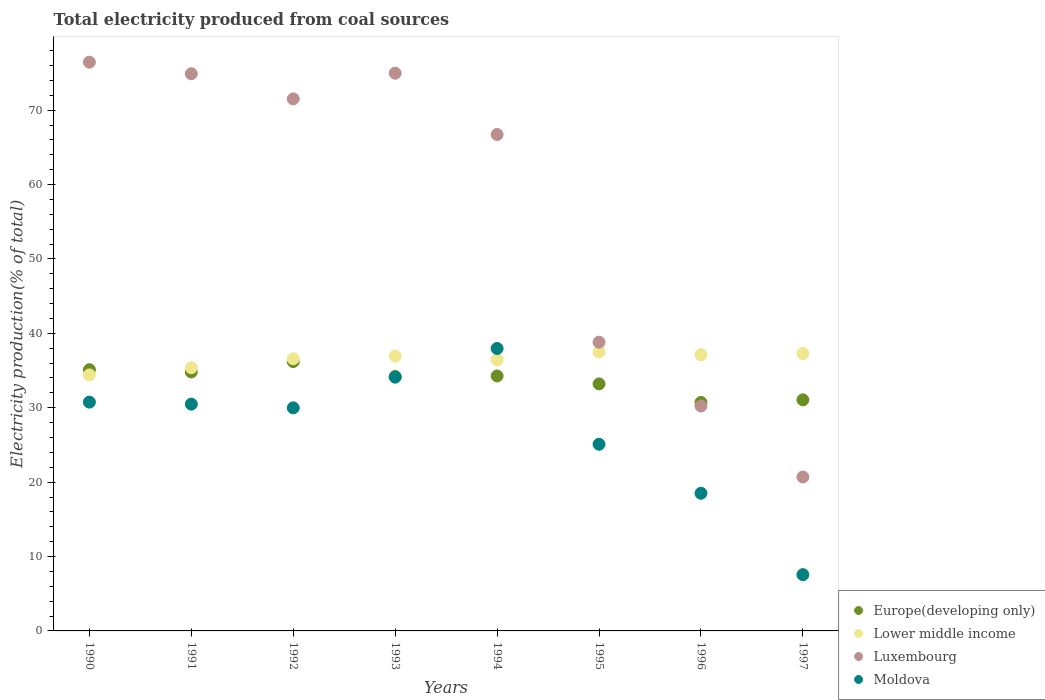Is the number of dotlines equal to the number of legend labels?
Offer a very short reply. Yes. What is the total electricity produced in Moldova in 1995?
Offer a terse response. 25.09. Across all years, what is the maximum total electricity produced in Moldova?
Your response must be concise. 37.96. Across all years, what is the minimum total electricity produced in Europe(developing only)?
Offer a very short reply. 30.71. In which year was the total electricity produced in Moldova maximum?
Keep it short and to the point. 1994. What is the total total electricity produced in Lower middle income in the graph?
Your response must be concise. 291.69. What is the difference between the total electricity produced in Luxembourg in 1993 and that in 1997?
Provide a short and direct response. 54.27. What is the difference between the total electricity produced in Moldova in 1994 and the total electricity produced in Lower middle income in 1996?
Provide a short and direct response. 0.83. What is the average total electricity produced in Luxembourg per year?
Make the answer very short. 56.78. In the year 1994, what is the difference between the total electricity produced in Europe(developing only) and total electricity produced in Lower middle income?
Provide a short and direct response. -2.18. In how many years, is the total electricity produced in Luxembourg greater than 52 %?
Make the answer very short. 5. What is the ratio of the total electricity produced in Europe(developing only) in 1990 to that in 1991?
Provide a succinct answer. 1.01. What is the difference between the highest and the second highest total electricity produced in Moldova?
Provide a succinct answer. 3.85. What is the difference between the highest and the lowest total electricity produced in Luxembourg?
Give a very brief answer. 55.75. In how many years, is the total electricity produced in Moldova greater than the average total electricity produced in Moldova taken over all years?
Offer a terse response. 5. Is the sum of the total electricity produced in Moldova in 1990 and 1994 greater than the maximum total electricity produced in Luxembourg across all years?
Give a very brief answer. No. Does the total electricity produced in Lower middle income monotonically increase over the years?
Provide a succinct answer. No. Is the total electricity produced in Luxembourg strictly greater than the total electricity produced in Europe(developing only) over the years?
Ensure brevity in your answer.  No. Is the total electricity produced in Lower middle income strictly less than the total electricity produced in Luxembourg over the years?
Your answer should be compact. No. How many years are there in the graph?
Your response must be concise. 8. Does the graph contain any zero values?
Provide a short and direct response. No. Does the graph contain grids?
Offer a very short reply. No. Where does the legend appear in the graph?
Offer a very short reply. Bottom right. How are the legend labels stacked?
Give a very brief answer. Vertical. What is the title of the graph?
Your response must be concise. Total electricity produced from coal sources. What is the Electricity production(% of total) of Europe(developing only) in 1990?
Ensure brevity in your answer.  35.11. What is the Electricity production(% of total) of Lower middle income in 1990?
Ensure brevity in your answer.  34.41. What is the Electricity production(% of total) of Luxembourg in 1990?
Offer a very short reply. 76.44. What is the Electricity production(% of total) of Moldova in 1990?
Ensure brevity in your answer.  30.75. What is the Electricity production(% of total) of Europe(developing only) in 1991?
Offer a terse response. 34.81. What is the Electricity production(% of total) in Lower middle income in 1991?
Provide a short and direct response. 35.38. What is the Electricity production(% of total) in Luxembourg in 1991?
Your answer should be compact. 74.89. What is the Electricity production(% of total) of Moldova in 1991?
Provide a short and direct response. 30.48. What is the Electricity production(% of total) in Europe(developing only) in 1992?
Make the answer very short. 36.2. What is the Electricity production(% of total) in Lower middle income in 1992?
Offer a terse response. 36.58. What is the Electricity production(% of total) in Luxembourg in 1992?
Offer a very short reply. 71.52. What is the Electricity production(% of total) in Moldova in 1992?
Offer a terse response. 29.99. What is the Electricity production(% of total) of Europe(developing only) in 1993?
Offer a very short reply. 34.2. What is the Electricity production(% of total) in Lower middle income in 1993?
Offer a terse response. 36.94. What is the Electricity production(% of total) in Luxembourg in 1993?
Provide a short and direct response. 74.96. What is the Electricity production(% of total) in Moldova in 1993?
Provide a short and direct response. 34.11. What is the Electricity production(% of total) in Europe(developing only) in 1994?
Ensure brevity in your answer.  34.27. What is the Electricity production(% of total) in Lower middle income in 1994?
Give a very brief answer. 36.46. What is the Electricity production(% of total) in Luxembourg in 1994?
Ensure brevity in your answer.  66.72. What is the Electricity production(% of total) of Moldova in 1994?
Ensure brevity in your answer.  37.96. What is the Electricity production(% of total) in Europe(developing only) in 1995?
Offer a terse response. 33.2. What is the Electricity production(% of total) of Lower middle income in 1995?
Offer a terse response. 37.52. What is the Electricity production(% of total) of Luxembourg in 1995?
Provide a short and direct response. 38.81. What is the Electricity production(% of total) of Moldova in 1995?
Offer a very short reply. 25.09. What is the Electricity production(% of total) of Europe(developing only) in 1996?
Keep it short and to the point. 30.71. What is the Electricity production(% of total) in Lower middle income in 1996?
Ensure brevity in your answer.  37.13. What is the Electricity production(% of total) of Luxembourg in 1996?
Provide a short and direct response. 30.23. What is the Electricity production(% of total) of Moldova in 1996?
Ensure brevity in your answer.  18.5. What is the Electricity production(% of total) in Europe(developing only) in 1997?
Offer a very short reply. 31.06. What is the Electricity production(% of total) in Lower middle income in 1997?
Offer a terse response. 37.27. What is the Electricity production(% of total) of Luxembourg in 1997?
Provide a succinct answer. 20.69. What is the Electricity production(% of total) of Moldova in 1997?
Provide a succinct answer. 7.56. Across all years, what is the maximum Electricity production(% of total) in Europe(developing only)?
Your answer should be very brief. 36.2. Across all years, what is the maximum Electricity production(% of total) of Lower middle income?
Give a very brief answer. 37.52. Across all years, what is the maximum Electricity production(% of total) of Luxembourg?
Give a very brief answer. 76.44. Across all years, what is the maximum Electricity production(% of total) in Moldova?
Provide a succinct answer. 37.96. Across all years, what is the minimum Electricity production(% of total) of Europe(developing only)?
Provide a short and direct response. 30.71. Across all years, what is the minimum Electricity production(% of total) of Lower middle income?
Your answer should be very brief. 34.41. Across all years, what is the minimum Electricity production(% of total) of Luxembourg?
Ensure brevity in your answer.  20.69. Across all years, what is the minimum Electricity production(% of total) of Moldova?
Give a very brief answer. 7.56. What is the total Electricity production(% of total) of Europe(developing only) in the graph?
Your answer should be very brief. 269.57. What is the total Electricity production(% of total) in Lower middle income in the graph?
Keep it short and to the point. 291.69. What is the total Electricity production(% of total) of Luxembourg in the graph?
Offer a very short reply. 454.26. What is the total Electricity production(% of total) in Moldova in the graph?
Ensure brevity in your answer.  214.45. What is the difference between the Electricity production(% of total) in Europe(developing only) in 1990 and that in 1991?
Keep it short and to the point. 0.31. What is the difference between the Electricity production(% of total) in Lower middle income in 1990 and that in 1991?
Your response must be concise. -0.97. What is the difference between the Electricity production(% of total) in Luxembourg in 1990 and that in 1991?
Offer a very short reply. 1.55. What is the difference between the Electricity production(% of total) of Moldova in 1990 and that in 1991?
Keep it short and to the point. 0.27. What is the difference between the Electricity production(% of total) in Europe(developing only) in 1990 and that in 1992?
Provide a succinct answer. -1.09. What is the difference between the Electricity production(% of total) of Lower middle income in 1990 and that in 1992?
Give a very brief answer. -2.18. What is the difference between the Electricity production(% of total) in Luxembourg in 1990 and that in 1992?
Ensure brevity in your answer.  4.93. What is the difference between the Electricity production(% of total) of Moldova in 1990 and that in 1992?
Your response must be concise. 0.76. What is the difference between the Electricity production(% of total) in Europe(developing only) in 1990 and that in 1993?
Provide a succinct answer. 0.91. What is the difference between the Electricity production(% of total) of Lower middle income in 1990 and that in 1993?
Keep it short and to the point. -2.53. What is the difference between the Electricity production(% of total) in Luxembourg in 1990 and that in 1993?
Make the answer very short. 1.48. What is the difference between the Electricity production(% of total) in Moldova in 1990 and that in 1993?
Provide a short and direct response. -3.36. What is the difference between the Electricity production(% of total) of Europe(developing only) in 1990 and that in 1994?
Your answer should be compact. 0.84. What is the difference between the Electricity production(% of total) of Lower middle income in 1990 and that in 1994?
Your answer should be compact. -2.05. What is the difference between the Electricity production(% of total) of Luxembourg in 1990 and that in 1994?
Offer a very short reply. 9.72. What is the difference between the Electricity production(% of total) in Moldova in 1990 and that in 1994?
Your response must be concise. -7.21. What is the difference between the Electricity production(% of total) in Europe(developing only) in 1990 and that in 1995?
Keep it short and to the point. 1.91. What is the difference between the Electricity production(% of total) in Lower middle income in 1990 and that in 1995?
Make the answer very short. -3.11. What is the difference between the Electricity production(% of total) in Luxembourg in 1990 and that in 1995?
Your answer should be very brief. 37.63. What is the difference between the Electricity production(% of total) of Moldova in 1990 and that in 1995?
Offer a terse response. 5.66. What is the difference between the Electricity production(% of total) of Europe(developing only) in 1990 and that in 1996?
Provide a succinct answer. 4.4. What is the difference between the Electricity production(% of total) in Lower middle income in 1990 and that in 1996?
Offer a terse response. -2.72. What is the difference between the Electricity production(% of total) of Luxembourg in 1990 and that in 1996?
Keep it short and to the point. 46.22. What is the difference between the Electricity production(% of total) in Moldova in 1990 and that in 1996?
Your answer should be very brief. 12.25. What is the difference between the Electricity production(% of total) of Europe(developing only) in 1990 and that in 1997?
Make the answer very short. 4.06. What is the difference between the Electricity production(% of total) of Lower middle income in 1990 and that in 1997?
Your answer should be very brief. -2.87. What is the difference between the Electricity production(% of total) of Luxembourg in 1990 and that in 1997?
Offer a very short reply. 55.75. What is the difference between the Electricity production(% of total) of Moldova in 1990 and that in 1997?
Provide a succinct answer. 23.19. What is the difference between the Electricity production(% of total) in Europe(developing only) in 1991 and that in 1992?
Your response must be concise. -1.39. What is the difference between the Electricity production(% of total) of Lower middle income in 1991 and that in 1992?
Make the answer very short. -1.21. What is the difference between the Electricity production(% of total) in Luxembourg in 1991 and that in 1992?
Offer a very short reply. 3.38. What is the difference between the Electricity production(% of total) in Moldova in 1991 and that in 1992?
Make the answer very short. 0.5. What is the difference between the Electricity production(% of total) of Europe(developing only) in 1991 and that in 1993?
Give a very brief answer. 0.61. What is the difference between the Electricity production(% of total) in Lower middle income in 1991 and that in 1993?
Provide a succinct answer. -1.56. What is the difference between the Electricity production(% of total) in Luxembourg in 1991 and that in 1993?
Ensure brevity in your answer.  -0.07. What is the difference between the Electricity production(% of total) in Moldova in 1991 and that in 1993?
Your response must be concise. -3.63. What is the difference between the Electricity production(% of total) of Europe(developing only) in 1991 and that in 1994?
Make the answer very short. 0.54. What is the difference between the Electricity production(% of total) of Lower middle income in 1991 and that in 1994?
Ensure brevity in your answer.  -1.08. What is the difference between the Electricity production(% of total) of Luxembourg in 1991 and that in 1994?
Offer a very short reply. 8.17. What is the difference between the Electricity production(% of total) in Moldova in 1991 and that in 1994?
Give a very brief answer. -7.48. What is the difference between the Electricity production(% of total) of Europe(developing only) in 1991 and that in 1995?
Ensure brevity in your answer.  1.61. What is the difference between the Electricity production(% of total) of Lower middle income in 1991 and that in 1995?
Your response must be concise. -2.14. What is the difference between the Electricity production(% of total) in Luxembourg in 1991 and that in 1995?
Keep it short and to the point. 36.08. What is the difference between the Electricity production(% of total) in Moldova in 1991 and that in 1995?
Keep it short and to the point. 5.39. What is the difference between the Electricity production(% of total) in Europe(developing only) in 1991 and that in 1996?
Provide a succinct answer. 4.1. What is the difference between the Electricity production(% of total) of Lower middle income in 1991 and that in 1996?
Give a very brief answer. -1.75. What is the difference between the Electricity production(% of total) of Luxembourg in 1991 and that in 1996?
Your answer should be compact. 44.67. What is the difference between the Electricity production(% of total) of Moldova in 1991 and that in 1996?
Provide a short and direct response. 11.98. What is the difference between the Electricity production(% of total) of Europe(developing only) in 1991 and that in 1997?
Your answer should be very brief. 3.75. What is the difference between the Electricity production(% of total) of Lower middle income in 1991 and that in 1997?
Your answer should be very brief. -1.9. What is the difference between the Electricity production(% of total) in Luxembourg in 1991 and that in 1997?
Make the answer very short. 54.2. What is the difference between the Electricity production(% of total) in Moldova in 1991 and that in 1997?
Give a very brief answer. 22.92. What is the difference between the Electricity production(% of total) in Europe(developing only) in 1992 and that in 1993?
Provide a succinct answer. 2. What is the difference between the Electricity production(% of total) of Lower middle income in 1992 and that in 1993?
Your answer should be compact. -0.35. What is the difference between the Electricity production(% of total) of Luxembourg in 1992 and that in 1993?
Your answer should be compact. -3.45. What is the difference between the Electricity production(% of total) of Moldova in 1992 and that in 1993?
Ensure brevity in your answer.  -4.12. What is the difference between the Electricity production(% of total) of Europe(developing only) in 1992 and that in 1994?
Give a very brief answer. 1.93. What is the difference between the Electricity production(% of total) in Lower middle income in 1992 and that in 1994?
Ensure brevity in your answer.  0.13. What is the difference between the Electricity production(% of total) of Luxembourg in 1992 and that in 1994?
Your answer should be compact. 4.79. What is the difference between the Electricity production(% of total) of Moldova in 1992 and that in 1994?
Offer a very short reply. -7.98. What is the difference between the Electricity production(% of total) in Europe(developing only) in 1992 and that in 1995?
Your response must be concise. 3. What is the difference between the Electricity production(% of total) of Lower middle income in 1992 and that in 1995?
Your answer should be compact. -0.94. What is the difference between the Electricity production(% of total) in Luxembourg in 1992 and that in 1995?
Your answer should be very brief. 32.71. What is the difference between the Electricity production(% of total) in Moldova in 1992 and that in 1995?
Your response must be concise. 4.9. What is the difference between the Electricity production(% of total) of Europe(developing only) in 1992 and that in 1996?
Ensure brevity in your answer.  5.49. What is the difference between the Electricity production(% of total) in Lower middle income in 1992 and that in 1996?
Provide a short and direct response. -0.55. What is the difference between the Electricity production(% of total) of Luxembourg in 1992 and that in 1996?
Provide a short and direct response. 41.29. What is the difference between the Electricity production(% of total) in Moldova in 1992 and that in 1996?
Give a very brief answer. 11.48. What is the difference between the Electricity production(% of total) in Europe(developing only) in 1992 and that in 1997?
Keep it short and to the point. 5.14. What is the difference between the Electricity production(% of total) in Lower middle income in 1992 and that in 1997?
Your answer should be compact. -0.69. What is the difference between the Electricity production(% of total) of Luxembourg in 1992 and that in 1997?
Offer a terse response. 50.83. What is the difference between the Electricity production(% of total) of Moldova in 1992 and that in 1997?
Keep it short and to the point. 22.42. What is the difference between the Electricity production(% of total) in Europe(developing only) in 1993 and that in 1994?
Provide a succinct answer. -0.07. What is the difference between the Electricity production(% of total) in Lower middle income in 1993 and that in 1994?
Make the answer very short. 0.48. What is the difference between the Electricity production(% of total) of Luxembourg in 1993 and that in 1994?
Keep it short and to the point. 8.24. What is the difference between the Electricity production(% of total) in Moldova in 1993 and that in 1994?
Provide a short and direct response. -3.85. What is the difference between the Electricity production(% of total) of Europe(developing only) in 1993 and that in 1995?
Provide a short and direct response. 1. What is the difference between the Electricity production(% of total) in Lower middle income in 1993 and that in 1995?
Offer a very short reply. -0.58. What is the difference between the Electricity production(% of total) of Luxembourg in 1993 and that in 1995?
Offer a very short reply. 36.15. What is the difference between the Electricity production(% of total) in Moldova in 1993 and that in 1995?
Give a very brief answer. 9.02. What is the difference between the Electricity production(% of total) in Europe(developing only) in 1993 and that in 1996?
Your response must be concise. 3.49. What is the difference between the Electricity production(% of total) in Lower middle income in 1993 and that in 1996?
Provide a succinct answer. -0.19. What is the difference between the Electricity production(% of total) in Luxembourg in 1993 and that in 1996?
Make the answer very short. 44.74. What is the difference between the Electricity production(% of total) of Moldova in 1993 and that in 1996?
Provide a succinct answer. 15.61. What is the difference between the Electricity production(% of total) of Europe(developing only) in 1993 and that in 1997?
Make the answer very short. 3.14. What is the difference between the Electricity production(% of total) of Lower middle income in 1993 and that in 1997?
Your answer should be very brief. -0.34. What is the difference between the Electricity production(% of total) in Luxembourg in 1993 and that in 1997?
Keep it short and to the point. 54.27. What is the difference between the Electricity production(% of total) in Moldova in 1993 and that in 1997?
Give a very brief answer. 26.54. What is the difference between the Electricity production(% of total) of Europe(developing only) in 1994 and that in 1995?
Offer a very short reply. 1.07. What is the difference between the Electricity production(% of total) of Lower middle income in 1994 and that in 1995?
Keep it short and to the point. -1.06. What is the difference between the Electricity production(% of total) of Luxembourg in 1994 and that in 1995?
Offer a terse response. 27.92. What is the difference between the Electricity production(% of total) in Moldova in 1994 and that in 1995?
Ensure brevity in your answer.  12.87. What is the difference between the Electricity production(% of total) of Europe(developing only) in 1994 and that in 1996?
Your response must be concise. 3.56. What is the difference between the Electricity production(% of total) in Lower middle income in 1994 and that in 1996?
Offer a terse response. -0.67. What is the difference between the Electricity production(% of total) in Luxembourg in 1994 and that in 1996?
Your answer should be compact. 36.5. What is the difference between the Electricity production(% of total) in Moldova in 1994 and that in 1996?
Provide a short and direct response. 19.46. What is the difference between the Electricity production(% of total) in Europe(developing only) in 1994 and that in 1997?
Keep it short and to the point. 3.21. What is the difference between the Electricity production(% of total) in Lower middle income in 1994 and that in 1997?
Your answer should be very brief. -0.82. What is the difference between the Electricity production(% of total) in Luxembourg in 1994 and that in 1997?
Keep it short and to the point. 46.03. What is the difference between the Electricity production(% of total) in Moldova in 1994 and that in 1997?
Your answer should be compact. 30.4. What is the difference between the Electricity production(% of total) of Europe(developing only) in 1995 and that in 1996?
Make the answer very short. 2.49. What is the difference between the Electricity production(% of total) of Lower middle income in 1995 and that in 1996?
Give a very brief answer. 0.39. What is the difference between the Electricity production(% of total) of Luxembourg in 1995 and that in 1996?
Give a very brief answer. 8.58. What is the difference between the Electricity production(% of total) of Moldova in 1995 and that in 1996?
Offer a very short reply. 6.59. What is the difference between the Electricity production(% of total) in Europe(developing only) in 1995 and that in 1997?
Your response must be concise. 2.14. What is the difference between the Electricity production(% of total) in Lower middle income in 1995 and that in 1997?
Give a very brief answer. 0.25. What is the difference between the Electricity production(% of total) in Luxembourg in 1995 and that in 1997?
Give a very brief answer. 18.12. What is the difference between the Electricity production(% of total) of Moldova in 1995 and that in 1997?
Your answer should be very brief. 17.52. What is the difference between the Electricity production(% of total) of Europe(developing only) in 1996 and that in 1997?
Your answer should be very brief. -0.35. What is the difference between the Electricity production(% of total) of Lower middle income in 1996 and that in 1997?
Your answer should be very brief. -0.14. What is the difference between the Electricity production(% of total) in Luxembourg in 1996 and that in 1997?
Make the answer very short. 9.54. What is the difference between the Electricity production(% of total) in Moldova in 1996 and that in 1997?
Your answer should be very brief. 10.94. What is the difference between the Electricity production(% of total) of Europe(developing only) in 1990 and the Electricity production(% of total) of Lower middle income in 1991?
Give a very brief answer. -0.26. What is the difference between the Electricity production(% of total) of Europe(developing only) in 1990 and the Electricity production(% of total) of Luxembourg in 1991?
Provide a succinct answer. -39.78. What is the difference between the Electricity production(% of total) in Europe(developing only) in 1990 and the Electricity production(% of total) in Moldova in 1991?
Keep it short and to the point. 4.63. What is the difference between the Electricity production(% of total) in Lower middle income in 1990 and the Electricity production(% of total) in Luxembourg in 1991?
Make the answer very short. -40.49. What is the difference between the Electricity production(% of total) in Lower middle income in 1990 and the Electricity production(% of total) in Moldova in 1991?
Make the answer very short. 3.92. What is the difference between the Electricity production(% of total) in Luxembourg in 1990 and the Electricity production(% of total) in Moldova in 1991?
Your answer should be very brief. 45.96. What is the difference between the Electricity production(% of total) in Europe(developing only) in 1990 and the Electricity production(% of total) in Lower middle income in 1992?
Provide a succinct answer. -1.47. What is the difference between the Electricity production(% of total) in Europe(developing only) in 1990 and the Electricity production(% of total) in Luxembourg in 1992?
Offer a terse response. -36.4. What is the difference between the Electricity production(% of total) of Europe(developing only) in 1990 and the Electricity production(% of total) of Moldova in 1992?
Ensure brevity in your answer.  5.13. What is the difference between the Electricity production(% of total) in Lower middle income in 1990 and the Electricity production(% of total) in Luxembourg in 1992?
Provide a short and direct response. -37.11. What is the difference between the Electricity production(% of total) in Lower middle income in 1990 and the Electricity production(% of total) in Moldova in 1992?
Offer a terse response. 4.42. What is the difference between the Electricity production(% of total) of Luxembourg in 1990 and the Electricity production(% of total) of Moldova in 1992?
Make the answer very short. 46.46. What is the difference between the Electricity production(% of total) in Europe(developing only) in 1990 and the Electricity production(% of total) in Lower middle income in 1993?
Ensure brevity in your answer.  -1.82. What is the difference between the Electricity production(% of total) in Europe(developing only) in 1990 and the Electricity production(% of total) in Luxembourg in 1993?
Offer a terse response. -39.85. What is the difference between the Electricity production(% of total) of Europe(developing only) in 1990 and the Electricity production(% of total) of Moldova in 1993?
Offer a very short reply. 1.01. What is the difference between the Electricity production(% of total) in Lower middle income in 1990 and the Electricity production(% of total) in Luxembourg in 1993?
Keep it short and to the point. -40.56. What is the difference between the Electricity production(% of total) of Lower middle income in 1990 and the Electricity production(% of total) of Moldova in 1993?
Provide a short and direct response. 0.3. What is the difference between the Electricity production(% of total) in Luxembourg in 1990 and the Electricity production(% of total) in Moldova in 1993?
Offer a terse response. 42.33. What is the difference between the Electricity production(% of total) in Europe(developing only) in 1990 and the Electricity production(% of total) in Lower middle income in 1994?
Offer a very short reply. -1.34. What is the difference between the Electricity production(% of total) of Europe(developing only) in 1990 and the Electricity production(% of total) of Luxembourg in 1994?
Offer a very short reply. -31.61. What is the difference between the Electricity production(% of total) of Europe(developing only) in 1990 and the Electricity production(% of total) of Moldova in 1994?
Your answer should be very brief. -2.85. What is the difference between the Electricity production(% of total) of Lower middle income in 1990 and the Electricity production(% of total) of Luxembourg in 1994?
Your response must be concise. -32.32. What is the difference between the Electricity production(% of total) in Lower middle income in 1990 and the Electricity production(% of total) in Moldova in 1994?
Keep it short and to the point. -3.56. What is the difference between the Electricity production(% of total) in Luxembourg in 1990 and the Electricity production(% of total) in Moldova in 1994?
Offer a terse response. 38.48. What is the difference between the Electricity production(% of total) in Europe(developing only) in 1990 and the Electricity production(% of total) in Lower middle income in 1995?
Offer a terse response. -2.41. What is the difference between the Electricity production(% of total) in Europe(developing only) in 1990 and the Electricity production(% of total) in Luxembourg in 1995?
Ensure brevity in your answer.  -3.69. What is the difference between the Electricity production(% of total) in Europe(developing only) in 1990 and the Electricity production(% of total) in Moldova in 1995?
Ensure brevity in your answer.  10.03. What is the difference between the Electricity production(% of total) in Lower middle income in 1990 and the Electricity production(% of total) in Luxembourg in 1995?
Offer a very short reply. -4.4. What is the difference between the Electricity production(% of total) of Lower middle income in 1990 and the Electricity production(% of total) of Moldova in 1995?
Provide a short and direct response. 9.32. What is the difference between the Electricity production(% of total) in Luxembourg in 1990 and the Electricity production(% of total) in Moldova in 1995?
Your answer should be very brief. 51.35. What is the difference between the Electricity production(% of total) of Europe(developing only) in 1990 and the Electricity production(% of total) of Lower middle income in 1996?
Ensure brevity in your answer.  -2.02. What is the difference between the Electricity production(% of total) in Europe(developing only) in 1990 and the Electricity production(% of total) in Luxembourg in 1996?
Ensure brevity in your answer.  4.89. What is the difference between the Electricity production(% of total) in Europe(developing only) in 1990 and the Electricity production(% of total) in Moldova in 1996?
Offer a terse response. 16.61. What is the difference between the Electricity production(% of total) in Lower middle income in 1990 and the Electricity production(% of total) in Luxembourg in 1996?
Keep it short and to the point. 4.18. What is the difference between the Electricity production(% of total) in Lower middle income in 1990 and the Electricity production(% of total) in Moldova in 1996?
Make the answer very short. 15.9. What is the difference between the Electricity production(% of total) in Luxembourg in 1990 and the Electricity production(% of total) in Moldova in 1996?
Your response must be concise. 57.94. What is the difference between the Electricity production(% of total) in Europe(developing only) in 1990 and the Electricity production(% of total) in Lower middle income in 1997?
Offer a terse response. -2.16. What is the difference between the Electricity production(% of total) of Europe(developing only) in 1990 and the Electricity production(% of total) of Luxembourg in 1997?
Make the answer very short. 14.42. What is the difference between the Electricity production(% of total) in Europe(developing only) in 1990 and the Electricity production(% of total) in Moldova in 1997?
Make the answer very short. 27.55. What is the difference between the Electricity production(% of total) of Lower middle income in 1990 and the Electricity production(% of total) of Luxembourg in 1997?
Your answer should be compact. 13.72. What is the difference between the Electricity production(% of total) in Lower middle income in 1990 and the Electricity production(% of total) in Moldova in 1997?
Give a very brief answer. 26.84. What is the difference between the Electricity production(% of total) of Luxembourg in 1990 and the Electricity production(% of total) of Moldova in 1997?
Provide a short and direct response. 68.88. What is the difference between the Electricity production(% of total) in Europe(developing only) in 1991 and the Electricity production(% of total) in Lower middle income in 1992?
Make the answer very short. -1.78. What is the difference between the Electricity production(% of total) of Europe(developing only) in 1991 and the Electricity production(% of total) of Luxembourg in 1992?
Your answer should be very brief. -36.71. What is the difference between the Electricity production(% of total) of Europe(developing only) in 1991 and the Electricity production(% of total) of Moldova in 1992?
Give a very brief answer. 4.82. What is the difference between the Electricity production(% of total) of Lower middle income in 1991 and the Electricity production(% of total) of Luxembourg in 1992?
Ensure brevity in your answer.  -36.14. What is the difference between the Electricity production(% of total) in Lower middle income in 1991 and the Electricity production(% of total) in Moldova in 1992?
Your answer should be very brief. 5.39. What is the difference between the Electricity production(% of total) in Luxembourg in 1991 and the Electricity production(% of total) in Moldova in 1992?
Ensure brevity in your answer.  44.91. What is the difference between the Electricity production(% of total) in Europe(developing only) in 1991 and the Electricity production(% of total) in Lower middle income in 1993?
Your answer should be very brief. -2.13. What is the difference between the Electricity production(% of total) in Europe(developing only) in 1991 and the Electricity production(% of total) in Luxembourg in 1993?
Ensure brevity in your answer.  -40.16. What is the difference between the Electricity production(% of total) of Europe(developing only) in 1991 and the Electricity production(% of total) of Moldova in 1993?
Your answer should be very brief. 0.7. What is the difference between the Electricity production(% of total) of Lower middle income in 1991 and the Electricity production(% of total) of Luxembourg in 1993?
Keep it short and to the point. -39.58. What is the difference between the Electricity production(% of total) of Lower middle income in 1991 and the Electricity production(% of total) of Moldova in 1993?
Make the answer very short. 1.27. What is the difference between the Electricity production(% of total) in Luxembourg in 1991 and the Electricity production(% of total) in Moldova in 1993?
Ensure brevity in your answer.  40.78. What is the difference between the Electricity production(% of total) in Europe(developing only) in 1991 and the Electricity production(% of total) in Lower middle income in 1994?
Offer a very short reply. -1.65. What is the difference between the Electricity production(% of total) of Europe(developing only) in 1991 and the Electricity production(% of total) of Luxembourg in 1994?
Provide a short and direct response. -31.92. What is the difference between the Electricity production(% of total) in Europe(developing only) in 1991 and the Electricity production(% of total) in Moldova in 1994?
Your answer should be very brief. -3.16. What is the difference between the Electricity production(% of total) of Lower middle income in 1991 and the Electricity production(% of total) of Luxembourg in 1994?
Provide a short and direct response. -31.35. What is the difference between the Electricity production(% of total) of Lower middle income in 1991 and the Electricity production(% of total) of Moldova in 1994?
Give a very brief answer. -2.58. What is the difference between the Electricity production(% of total) of Luxembourg in 1991 and the Electricity production(% of total) of Moldova in 1994?
Ensure brevity in your answer.  36.93. What is the difference between the Electricity production(% of total) of Europe(developing only) in 1991 and the Electricity production(% of total) of Lower middle income in 1995?
Ensure brevity in your answer.  -2.71. What is the difference between the Electricity production(% of total) in Europe(developing only) in 1991 and the Electricity production(% of total) in Luxembourg in 1995?
Offer a very short reply. -4. What is the difference between the Electricity production(% of total) in Europe(developing only) in 1991 and the Electricity production(% of total) in Moldova in 1995?
Offer a very short reply. 9.72. What is the difference between the Electricity production(% of total) in Lower middle income in 1991 and the Electricity production(% of total) in Luxembourg in 1995?
Your response must be concise. -3.43. What is the difference between the Electricity production(% of total) of Lower middle income in 1991 and the Electricity production(% of total) of Moldova in 1995?
Offer a terse response. 10.29. What is the difference between the Electricity production(% of total) of Luxembourg in 1991 and the Electricity production(% of total) of Moldova in 1995?
Your response must be concise. 49.8. What is the difference between the Electricity production(% of total) in Europe(developing only) in 1991 and the Electricity production(% of total) in Lower middle income in 1996?
Make the answer very short. -2.32. What is the difference between the Electricity production(% of total) in Europe(developing only) in 1991 and the Electricity production(% of total) in Luxembourg in 1996?
Offer a terse response. 4.58. What is the difference between the Electricity production(% of total) in Europe(developing only) in 1991 and the Electricity production(% of total) in Moldova in 1996?
Provide a short and direct response. 16.3. What is the difference between the Electricity production(% of total) in Lower middle income in 1991 and the Electricity production(% of total) in Luxembourg in 1996?
Provide a succinct answer. 5.15. What is the difference between the Electricity production(% of total) of Lower middle income in 1991 and the Electricity production(% of total) of Moldova in 1996?
Ensure brevity in your answer.  16.88. What is the difference between the Electricity production(% of total) in Luxembourg in 1991 and the Electricity production(% of total) in Moldova in 1996?
Give a very brief answer. 56.39. What is the difference between the Electricity production(% of total) of Europe(developing only) in 1991 and the Electricity production(% of total) of Lower middle income in 1997?
Give a very brief answer. -2.47. What is the difference between the Electricity production(% of total) of Europe(developing only) in 1991 and the Electricity production(% of total) of Luxembourg in 1997?
Provide a short and direct response. 14.12. What is the difference between the Electricity production(% of total) in Europe(developing only) in 1991 and the Electricity production(% of total) in Moldova in 1997?
Keep it short and to the point. 27.24. What is the difference between the Electricity production(% of total) of Lower middle income in 1991 and the Electricity production(% of total) of Luxembourg in 1997?
Offer a terse response. 14.69. What is the difference between the Electricity production(% of total) of Lower middle income in 1991 and the Electricity production(% of total) of Moldova in 1997?
Keep it short and to the point. 27.81. What is the difference between the Electricity production(% of total) of Luxembourg in 1991 and the Electricity production(% of total) of Moldova in 1997?
Give a very brief answer. 67.33. What is the difference between the Electricity production(% of total) in Europe(developing only) in 1992 and the Electricity production(% of total) in Lower middle income in 1993?
Keep it short and to the point. -0.74. What is the difference between the Electricity production(% of total) of Europe(developing only) in 1992 and the Electricity production(% of total) of Luxembourg in 1993?
Give a very brief answer. -38.76. What is the difference between the Electricity production(% of total) of Europe(developing only) in 1992 and the Electricity production(% of total) of Moldova in 1993?
Keep it short and to the point. 2.09. What is the difference between the Electricity production(% of total) of Lower middle income in 1992 and the Electricity production(% of total) of Luxembourg in 1993?
Make the answer very short. -38.38. What is the difference between the Electricity production(% of total) in Lower middle income in 1992 and the Electricity production(% of total) in Moldova in 1993?
Provide a short and direct response. 2.48. What is the difference between the Electricity production(% of total) in Luxembourg in 1992 and the Electricity production(% of total) in Moldova in 1993?
Your response must be concise. 37.41. What is the difference between the Electricity production(% of total) of Europe(developing only) in 1992 and the Electricity production(% of total) of Lower middle income in 1994?
Your response must be concise. -0.26. What is the difference between the Electricity production(% of total) in Europe(developing only) in 1992 and the Electricity production(% of total) in Luxembourg in 1994?
Offer a terse response. -30.52. What is the difference between the Electricity production(% of total) of Europe(developing only) in 1992 and the Electricity production(% of total) of Moldova in 1994?
Provide a succinct answer. -1.76. What is the difference between the Electricity production(% of total) of Lower middle income in 1992 and the Electricity production(% of total) of Luxembourg in 1994?
Keep it short and to the point. -30.14. What is the difference between the Electricity production(% of total) of Lower middle income in 1992 and the Electricity production(% of total) of Moldova in 1994?
Keep it short and to the point. -1.38. What is the difference between the Electricity production(% of total) in Luxembourg in 1992 and the Electricity production(% of total) in Moldova in 1994?
Provide a short and direct response. 33.55. What is the difference between the Electricity production(% of total) in Europe(developing only) in 1992 and the Electricity production(% of total) in Lower middle income in 1995?
Provide a succinct answer. -1.32. What is the difference between the Electricity production(% of total) of Europe(developing only) in 1992 and the Electricity production(% of total) of Luxembourg in 1995?
Your answer should be compact. -2.61. What is the difference between the Electricity production(% of total) in Europe(developing only) in 1992 and the Electricity production(% of total) in Moldova in 1995?
Offer a very short reply. 11.11. What is the difference between the Electricity production(% of total) in Lower middle income in 1992 and the Electricity production(% of total) in Luxembourg in 1995?
Ensure brevity in your answer.  -2.22. What is the difference between the Electricity production(% of total) of Lower middle income in 1992 and the Electricity production(% of total) of Moldova in 1995?
Keep it short and to the point. 11.5. What is the difference between the Electricity production(% of total) in Luxembourg in 1992 and the Electricity production(% of total) in Moldova in 1995?
Give a very brief answer. 46.43. What is the difference between the Electricity production(% of total) of Europe(developing only) in 1992 and the Electricity production(% of total) of Lower middle income in 1996?
Provide a succinct answer. -0.93. What is the difference between the Electricity production(% of total) of Europe(developing only) in 1992 and the Electricity production(% of total) of Luxembourg in 1996?
Provide a short and direct response. 5.97. What is the difference between the Electricity production(% of total) of Europe(developing only) in 1992 and the Electricity production(% of total) of Moldova in 1996?
Offer a very short reply. 17.7. What is the difference between the Electricity production(% of total) of Lower middle income in 1992 and the Electricity production(% of total) of Luxembourg in 1996?
Your answer should be compact. 6.36. What is the difference between the Electricity production(% of total) in Lower middle income in 1992 and the Electricity production(% of total) in Moldova in 1996?
Give a very brief answer. 18.08. What is the difference between the Electricity production(% of total) in Luxembourg in 1992 and the Electricity production(% of total) in Moldova in 1996?
Your answer should be compact. 53.01. What is the difference between the Electricity production(% of total) of Europe(developing only) in 1992 and the Electricity production(% of total) of Lower middle income in 1997?
Make the answer very short. -1.07. What is the difference between the Electricity production(% of total) in Europe(developing only) in 1992 and the Electricity production(% of total) in Luxembourg in 1997?
Offer a terse response. 15.51. What is the difference between the Electricity production(% of total) of Europe(developing only) in 1992 and the Electricity production(% of total) of Moldova in 1997?
Ensure brevity in your answer.  28.64. What is the difference between the Electricity production(% of total) of Lower middle income in 1992 and the Electricity production(% of total) of Luxembourg in 1997?
Your response must be concise. 15.89. What is the difference between the Electricity production(% of total) in Lower middle income in 1992 and the Electricity production(% of total) in Moldova in 1997?
Your answer should be very brief. 29.02. What is the difference between the Electricity production(% of total) of Luxembourg in 1992 and the Electricity production(% of total) of Moldova in 1997?
Provide a short and direct response. 63.95. What is the difference between the Electricity production(% of total) in Europe(developing only) in 1993 and the Electricity production(% of total) in Lower middle income in 1994?
Provide a succinct answer. -2.26. What is the difference between the Electricity production(% of total) in Europe(developing only) in 1993 and the Electricity production(% of total) in Luxembourg in 1994?
Provide a short and direct response. -32.52. What is the difference between the Electricity production(% of total) of Europe(developing only) in 1993 and the Electricity production(% of total) of Moldova in 1994?
Provide a short and direct response. -3.76. What is the difference between the Electricity production(% of total) of Lower middle income in 1993 and the Electricity production(% of total) of Luxembourg in 1994?
Keep it short and to the point. -29.79. What is the difference between the Electricity production(% of total) of Lower middle income in 1993 and the Electricity production(% of total) of Moldova in 1994?
Provide a short and direct response. -1.03. What is the difference between the Electricity production(% of total) of Luxembourg in 1993 and the Electricity production(% of total) of Moldova in 1994?
Keep it short and to the point. 37. What is the difference between the Electricity production(% of total) in Europe(developing only) in 1993 and the Electricity production(% of total) in Lower middle income in 1995?
Give a very brief answer. -3.32. What is the difference between the Electricity production(% of total) in Europe(developing only) in 1993 and the Electricity production(% of total) in Luxembourg in 1995?
Make the answer very short. -4.61. What is the difference between the Electricity production(% of total) of Europe(developing only) in 1993 and the Electricity production(% of total) of Moldova in 1995?
Your answer should be compact. 9.11. What is the difference between the Electricity production(% of total) of Lower middle income in 1993 and the Electricity production(% of total) of Luxembourg in 1995?
Your answer should be compact. -1.87. What is the difference between the Electricity production(% of total) in Lower middle income in 1993 and the Electricity production(% of total) in Moldova in 1995?
Give a very brief answer. 11.85. What is the difference between the Electricity production(% of total) in Luxembourg in 1993 and the Electricity production(% of total) in Moldova in 1995?
Your answer should be very brief. 49.87. What is the difference between the Electricity production(% of total) in Europe(developing only) in 1993 and the Electricity production(% of total) in Lower middle income in 1996?
Give a very brief answer. -2.93. What is the difference between the Electricity production(% of total) of Europe(developing only) in 1993 and the Electricity production(% of total) of Luxembourg in 1996?
Ensure brevity in your answer.  3.97. What is the difference between the Electricity production(% of total) of Europe(developing only) in 1993 and the Electricity production(% of total) of Moldova in 1996?
Give a very brief answer. 15.7. What is the difference between the Electricity production(% of total) of Lower middle income in 1993 and the Electricity production(% of total) of Luxembourg in 1996?
Provide a short and direct response. 6.71. What is the difference between the Electricity production(% of total) in Lower middle income in 1993 and the Electricity production(% of total) in Moldova in 1996?
Keep it short and to the point. 18.43. What is the difference between the Electricity production(% of total) in Luxembourg in 1993 and the Electricity production(% of total) in Moldova in 1996?
Provide a short and direct response. 56.46. What is the difference between the Electricity production(% of total) of Europe(developing only) in 1993 and the Electricity production(% of total) of Lower middle income in 1997?
Provide a succinct answer. -3.07. What is the difference between the Electricity production(% of total) in Europe(developing only) in 1993 and the Electricity production(% of total) in Luxembourg in 1997?
Keep it short and to the point. 13.51. What is the difference between the Electricity production(% of total) in Europe(developing only) in 1993 and the Electricity production(% of total) in Moldova in 1997?
Give a very brief answer. 26.64. What is the difference between the Electricity production(% of total) of Lower middle income in 1993 and the Electricity production(% of total) of Luxembourg in 1997?
Provide a short and direct response. 16.25. What is the difference between the Electricity production(% of total) of Lower middle income in 1993 and the Electricity production(% of total) of Moldova in 1997?
Ensure brevity in your answer.  29.37. What is the difference between the Electricity production(% of total) of Luxembourg in 1993 and the Electricity production(% of total) of Moldova in 1997?
Keep it short and to the point. 67.4. What is the difference between the Electricity production(% of total) in Europe(developing only) in 1994 and the Electricity production(% of total) in Lower middle income in 1995?
Keep it short and to the point. -3.25. What is the difference between the Electricity production(% of total) of Europe(developing only) in 1994 and the Electricity production(% of total) of Luxembourg in 1995?
Your answer should be compact. -4.54. What is the difference between the Electricity production(% of total) in Europe(developing only) in 1994 and the Electricity production(% of total) in Moldova in 1995?
Provide a short and direct response. 9.18. What is the difference between the Electricity production(% of total) of Lower middle income in 1994 and the Electricity production(% of total) of Luxembourg in 1995?
Offer a very short reply. -2.35. What is the difference between the Electricity production(% of total) of Lower middle income in 1994 and the Electricity production(% of total) of Moldova in 1995?
Offer a very short reply. 11.37. What is the difference between the Electricity production(% of total) of Luxembourg in 1994 and the Electricity production(% of total) of Moldova in 1995?
Provide a succinct answer. 41.64. What is the difference between the Electricity production(% of total) in Europe(developing only) in 1994 and the Electricity production(% of total) in Lower middle income in 1996?
Make the answer very short. -2.86. What is the difference between the Electricity production(% of total) in Europe(developing only) in 1994 and the Electricity production(% of total) in Luxembourg in 1996?
Offer a terse response. 4.04. What is the difference between the Electricity production(% of total) in Europe(developing only) in 1994 and the Electricity production(% of total) in Moldova in 1996?
Your answer should be very brief. 15.77. What is the difference between the Electricity production(% of total) in Lower middle income in 1994 and the Electricity production(% of total) in Luxembourg in 1996?
Make the answer very short. 6.23. What is the difference between the Electricity production(% of total) of Lower middle income in 1994 and the Electricity production(% of total) of Moldova in 1996?
Your answer should be very brief. 17.95. What is the difference between the Electricity production(% of total) of Luxembourg in 1994 and the Electricity production(% of total) of Moldova in 1996?
Give a very brief answer. 48.22. What is the difference between the Electricity production(% of total) of Europe(developing only) in 1994 and the Electricity production(% of total) of Lower middle income in 1997?
Offer a terse response. -3. What is the difference between the Electricity production(% of total) of Europe(developing only) in 1994 and the Electricity production(% of total) of Luxembourg in 1997?
Your answer should be very brief. 13.58. What is the difference between the Electricity production(% of total) of Europe(developing only) in 1994 and the Electricity production(% of total) of Moldova in 1997?
Offer a terse response. 26.71. What is the difference between the Electricity production(% of total) in Lower middle income in 1994 and the Electricity production(% of total) in Luxembourg in 1997?
Provide a succinct answer. 15.77. What is the difference between the Electricity production(% of total) in Lower middle income in 1994 and the Electricity production(% of total) in Moldova in 1997?
Your response must be concise. 28.89. What is the difference between the Electricity production(% of total) of Luxembourg in 1994 and the Electricity production(% of total) of Moldova in 1997?
Offer a terse response. 59.16. What is the difference between the Electricity production(% of total) in Europe(developing only) in 1995 and the Electricity production(% of total) in Lower middle income in 1996?
Make the answer very short. -3.93. What is the difference between the Electricity production(% of total) of Europe(developing only) in 1995 and the Electricity production(% of total) of Luxembourg in 1996?
Offer a terse response. 2.97. What is the difference between the Electricity production(% of total) of Europe(developing only) in 1995 and the Electricity production(% of total) of Moldova in 1996?
Keep it short and to the point. 14.7. What is the difference between the Electricity production(% of total) in Lower middle income in 1995 and the Electricity production(% of total) in Luxembourg in 1996?
Make the answer very short. 7.29. What is the difference between the Electricity production(% of total) of Lower middle income in 1995 and the Electricity production(% of total) of Moldova in 1996?
Your answer should be compact. 19.02. What is the difference between the Electricity production(% of total) of Luxembourg in 1995 and the Electricity production(% of total) of Moldova in 1996?
Your response must be concise. 20.31. What is the difference between the Electricity production(% of total) of Europe(developing only) in 1995 and the Electricity production(% of total) of Lower middle income in 1997?
Ensure brevity in your answer.  -4.07. What is the difference between the Electricity production(% of total) of Europe(developing only) in 1995 and the Electricity production(% of total) of Luxembourg in 1997?
Give a very brief answer. 12.51. What is the difference between the Electricity production(% of total) of Europe(developing only) in 1995 and the Electricity production(% of total) of Moldova in 1997?
Offer a very short reply. 25.64. What is the difference between the Electricity production(% of total) of Lower middle income in 1995 and the Electricity production(% of total) of Luxembourg in 1997?
Your response must be concise. 16.83. What is the difference between the Electricity production(% of total) in Lower middle income in 1995 and the Electricity production(% of total) in Moldova in 1997?
Offer a terse response. 29.96. What is the difference between the Electricity production(% of total) of Luxembourg in 1995 and the Electricity production(% of total) of Moldova in 1997?
Make the answer very short. 31.24. What is the difference between the Electricity production(% of total) in Europe(developing only) in 1996 and the Electricity production(% of total) in Lower middle income in 1997?
Your answer should be very brief. -6.56. What is the difference between the Electricity production(% of total) in Europe(developing only) in 1996 and the Electricity production(% of total) in Luxembourg in 1997?
Ensure brevity in your answer.  10.02. What is the difference between the Electricity production(% of total) of Europe(developing only) in 1996 and the Electricity production(% of total) of Moldova in 1997?
Provide a short and direct response. 23.15. What is the difference between the Electricity production(% of total) of Lower middle income in 1996 and the Electricity production(% of total) of Luxembourg in 1997?
Your answer should be very brief. 16.44. What is the difference between the Electricity production(% of total) in Lower middle income in 1996 and the Electricity production(% of total) in Moldova in 1997?
Your answer should be compact. 29.57. What is the difference between the Electricity production(% of total) of Luxembourg in 1996 and the Electricity production(% of total) of Moldova in 1997?
Make the answer very short. 22.66. What is the average Electricity production(% of total) of Europe(developing only) per year?
Make the answer very short. 33.7. What is the average Electricity production(% of total) of Lower middle income per year?
Provide a succinct answer. 36.46. What is the average Electricity production(% of total) in Luxembourg per year?
Your answer should be very brief. 56.78. What is the average Electricity production(% of total) of Moldova per year?
Your response must be concise. 26.81. In the year 1990, what is the difference between the Electricity production(% of total) in Europe(developing only) and Electricity production(% of total) in Lower middle income?
Your response must be concise. 0.71. In the year 1990, what is the difference between the Electricity production(% of total) of Europe(developing only) and Electricity production(% of total) of Luxembourg?
Ensure brevity in your answer.  -41.33. In the year 1990, what is the difference between the Electricity production(% of total) in Europe(developing only) and Electricity production(% of total) in Moldova?
Keep it short and to the point. 4.36. In the year 1990, what is the difference between the Electricity production(% of total) of Lower middle income and Electricity production(% of total) of Luxembourg?
Make the answer very short. -42.04. In the year 1990, what is the difference between the Electricity production(% of total) of Lower middle income and Electricity production(% of total) of Moldova?
Your answer should be very brief. 3.66. In the year 1990, what is the difference between the Electricity production(% of total) in Luxembourg and Electricity production(% of total) in Moldova?
Your response must be concise. 45.69. In the year 1991, what is the difference between the Electricity production(% of total) in Europe(developing only) and Electricity production(% of total) in Lower middle income?
Make the answer very short. -0.57. In the year 1991, what is the difference between the Electricity production(% of total) of Europe(developing only) and Electricity production(% of total) of Luxembourg?
Give a very brief answer. -40.09. In the year 1991, what is the difference between the Electricity production(% of total) of Europe(developing only) and Electricity production(% of total) of Moldova?
Ensure brevity in your answer.  4.32. In the year 1991, what is the difference between the Electricity production(% of total) in Lower middle income and Electricity production(% of total) in Luxembourg?
Your answer should be compact. -39.51. In the year 1991, what is the difference between the Electricity production(% of total) in Lower middle income and Electricity production(% of total) in Moldova?
Provide a short and direct response. 4.9. In the year 1991, what is the difference between the Electricity production(% of total) in Luxembourg and Electricity production(% of total) in Moldova?
Provide a succinct answer. 44.41. In the year 1992, what is the difference between the Electricity production(% of total) in Europe(developing only) and Electricity production(% of total) in Lower middle income?
Provide a short and direct response. -0.38. In the year 1992, what is the difference between the Electricity production(% of total) in Europe(developing only) and Electricity production(% of total) in Luxembourg?
Offer a very short reply. -35.32. In the year 1992, what is the difference between the Electricity production(% of total) of Europe(developing only) and Electricity production(% of total) of Moldova?
Your response must be concise. 6.21. In the year 1992, what is the difference between the Electricity production(% of total) of Lower middle income and Electricity production(% of total) of Luxembourg?
Provide a succinct answer. -34.93. In the year 1992, what is the difference between the Electricity production(% of total) of Lower middle income and Electricity production(% of total) of Moldova?
Keep it short and to the point. 6.6. In the year 1992, what is the difference between the Electricity production(% of total) in Luxembourg and Electricity production(% of total) in Moldova?
Offer a terse response. 41.53. In the year 1993, what is the difference between the Electricity production(% of total) of Europe(developing only) and Electricity production(% of total) of Lower middle income?
Your answer should be very brief. -2.74. In the year 1993, what is the difference between the Electricity production(% of total) in Europe(developing only) and Electricity production(% of total) in Luxembourg?
Offer a very short reply. -40.76. In the year 1993, what is the difference between the Electricity production(% of total) in Europe(developing only) and Electricity production(% of total) in Moldova?
Your answer should be very brief. 0.09. In the year 1993, what is the difference between the Electricity production(% of total) in Lower middle income and Electricity production(% of total) in Luxembourg?
Offer a very short reply. -38.03. In the year 1993, what is the difference between the Electricity production(% of total) in Lower middle income and Electricity production(% of total) in Moldova?
Offer a very short reply. 2.83. In the year 1993, what is the difference between the Electricity production(% of total) of Luxembourg and Electricity production(% of total) of Moldova?
Your answer should be compact. 40.85. In the year 1994, what is the difference between the Electricity production(% of total) in Europe(developing only) and Electricity production(% of total) in Lower middle income?
Your answer should be compact. -2.18. In the year 1994, what is the difference between the Electricity production(% of total) in Europe(developing only) and Electricity production(% of total) in Luxembourg?
Offer a terse response. -32.45. In the year 1994, what is the difference between the Electricity production(% of total) in Europe(developing only) and Electricity production(% of total) in Moldova?
Your answer should be very brief. -3.69. In the year 1994, what is the difference between the Electricity production(% of total) of Lower middle income and Electricity production(% of total) of Luxembourg?
Keep it short and to the point. -30.27. In the year 1994, what is the difference between the Electricity production(% of total) of Lower middle income and Electricity production(% of total) of Moldova?
Your response must be concise. -1.51. In the year 1994, what is the difference between the Electricity production(% of total) in Luxembourg and Electricity production(% of total) in Moldova?
Give a very brief answer. 28.76. In the year 1995, what is the difference between the Electricity production(% of total) in Europe(developing only) and Electricity production(% of total) in Lower middle income?
Offer a terse response. -4.32. In the year 1995, what is the difference between the Electricity production(% of total) of Europe(developing only) and Electricity production(% of total) of Luxembourg?
Your answer should be very brief. -5.61. In the year 1995, what is the difference between the Electricity production(% of total) in Europe(developing only) and Electricity production(% of total) in Moldova?
Offer a terse response. 8.11. In the year 1995, what is the difference between the Electricity production(% of total) in Lower middle income and Electricity production(% of total) in Luxembourg?
Ensure brevity in your answer.  -1.29. In the year 1995, what is the difference between the Electricity production(% of total) in Lower middle income and Electricity production(% of total) in Moldova?
Make the answer very short. 12.43. In the year 1995, what is the difference between the Electricity production(% of total) of Luxembourg and Electricity production(% of total) of Moldova?
Ensure brevity in your answer.  13.72. In the year 1996, what is the difference between the Electricity production(% of total) of Europe(developing only) and Electricity production(% of total) of Lower middle income?
Give a very brief answer. -6.42. In the year 1996, what is the difference between the Electricity production(% of total) in Europe(developing only) and Electricity production(% of total) in Luxembourg?
Provide a succinct answer. 0.48. In the year 1996, what is the difference between the Electricity production(% of total) of Europe(developing only) and Electricity production(% of total) of Moldova?
Offer a terse response. 12.21. In the year 1996, what is the difference between the Electricity production(% of total) in Lower middle income and Electricity production(% of total) in Luxembourg?
Your answer should be compact. 6.9. In the year 1996, what is the difference between the Electricity production(% of total) in Lower middle income and Electricity production(% of total) in Moldova?
Make the answer very short. 18.63. In the year 1996, what is the difference between the Electricity production(% of total) in Luxembourg and Electricity production(% of total) in Moldova?
Your response must be concise. 11.72. In the year 1997, what is the difference between the Electricity production(% of total) in Europe(developing only) and Electricity production(% of total) in Lower middle income?
Offer a very short reply. -6.22. In the year 1997, what is the difference between the Electricity production(% of total) in Europe(developing only) and Electricity production(% of total) in Luxembourg?
Provide a succinct answer. 10.37. In the year 1997, what is the difference between the Electricity production(% of total) in Europe(developing only) and Electricity production(% of total) in Moldova?
Provide a succinct answer. 23.49. In the year 1997, what is the difference between the Electricity production(% of total) in Lower middle income and Electricity production(% of total) in Luxembourg?
Ensure brevity in your answer.  16.59. In the year 1997, what is the difference between the Electricity production(% of total) of Lower middle income and Electricity production(% of total) of Moldova?
Make the answer very short. 29.71. In the year 1997, what is the difference between the Electricity production(% of total) in Luxembourg and Electricity production(% of total) in Moldova?
Keep it short and to the point. 13.12. What is the ratio of the Electricity production(% of total) of Europe(developing only) in 1990 to that in 1991?
Give a very brief answer. 1.01. What is the ratio of the Electricity production(% of total) in Lower middle income in 1990 to that in 1991?
Offer a terse response. 0.97. What is the ratio of the Electricity production(% of total) of Luxembourg in 1990 to that in 1991?
Provide a short and direct response. 1.02. What is the ratio of the Electricity production(% of total) of Moldova in 1990 to that in 1991?
Your answer should be very brief. 1.01. What is the ratio of the Electricity production(% of total) of Europe(developing only) in 1990 to that in 1992?
Your answer should be very brief. 0.97. What is the ratio of the Electricity production(% of total) in Lower middle income in 1990 to that in 1992?
Provide a short and direct response. 0.94. What is the ratio of the Electricity production(% of total) in Luxembourg in 1990 to that in 1992?
Your response must be concise. 1.07. What is the ratio of the Electricity production(% of total) in Moldova in 1990 to that in 1992?
Give a very brief answer. 1.03. What is the ratio of the Electricity production(% of total) in Europe(developing only) in 1990 to that in 1993?
Make the answer very short. 1.03. What is the ratio of the Electricity production(% of total) in Lower middle income in 1990 to that in 1993?
Give a very brief answer. 0.93. What is the ratio of the Electricity production(% of total) in Luxembourg in 1990 to that in 1993?
Your answer should be very brief. 1.02. What is the ratio of the Electricity production(% of total) in Moldova in 1990 to that in 1993?
Your answer should be compact. 0.9. What is the ratio of the Electricity production(% of total) of Europe(developing only) in 1990 to that in 1994?
Ensure brevity in your answer.  1.02. What is the ratio of the Electricity production(% of total) of Lower middle income in 1990 to that in 1994?
Offer a very short reply. 0.94. What is the ratio of the Electricity production(% of total) in Luxembourg in 1990 to that in 1994?
Your answer should be compact. 1.15. What is the ratio of the Electricity production(% of total) in Moldova in 1990 to that in 1994?
Offer a very short reply. 0.81. What is the ratio of the Electricity production(% of total) of Europe(developing only) in 1990 to that in 1995?
Your response must be concise. 1.06. What is the ratio of the Electricity production(% of total) in Lower middle income in 1990 to that in 1995?
Provide a short and direct response. 0.92. What is the ratio of the Electricity production(% of total) in Luxembourg in 1990 to that in 1995?
Your answer should be compact. 1.97. What is the ratio of the Electricity production(% of total) of Moldova in 1990 to that in 1995?
Offer a very short reply. 1.23. What is the ratio of the Electricity production(% of total) in Europe(developing only) in 1990 to that in 1996?
Offer a very short reply. 1.14. What is the ratio of the Electricity production(% of total) in Lower middle income in 1990 to that in 1996?
Your answer should be very brief. 0.93. What is the ratio of the Electricity production(% of total) in Luxembourg in 1990 to that in 1996?
Offer a terse response. 2.53. What is the ratio of the Electricity production(% of total) in Moldova in 1990 to that in 1996?
Offer a terse response. 1.66. What is the ratio of the Electricity production(% of total) of Europe(developing only) in 1990 to that in 1997?
Your answer should be very brief. 1.13. What is the ratio of the Electricity production(% of total) in Lower middle income in 1990 to that in 1997?
Offer a very short reply. 0.92. What is the ratio of the Electricity production(% of total) of Luxembourg in 1990 to that in 1997?
Offer a terse response. 3.69. What is the ratio of the Electricity production(% of total) in Moldova in 1990 to that in 1997?
Your response must be concise. 4.07. What is the ratio of the Electricity production(% of total) of Europe(developing only) in 1991 to that in 1992?
Your answer should be very brief. 0.96. What is the ratio of the Electricity production(% of total) of Luxembourg in 1991 to that in 1992?
Make the answer very short. 1.05. What is the ratio of the Electricity production(% of total) of Moldova in 1991 to that in 1992?
Keep it short and to the point. 1.02. What is the ratio of the Electricity production(% of total) in Europe(developing only) in 1991 to that in 1993?
Your response must be concise. 1.02. What is the ratio of the Electricity production(% of total) in Lower middle income in 1991 to that in 1993?
Offer a very short reply. 0.96. What is the ratio of the Electricity production(% of total) of Moldova in 1991 to that in 1993?
Provide a succinct answer. 0.89. What is the ratio of the Electricity production(% of total) in Europe(developing only) in 1991 to that in 1994?
Your answer should be very brief. 1.02. What is the ratio of the Electricity production(% of total) of Lower middle income in 1991 to that in 1994?
Keep it short and to the point. 0.97. What is the ratio of the Electricity production(% of total) in Luxembourg in 1991 to that in 1994?
Ensure brevity in your answer.  1.12. What is the ratio of the Electricity production(% of total) of Moldova in 1991 to that in 1994?
Your answer should be very brief. 0.8. What is the ratio of the Electricity production(% of total) of Europe(developing only) in 1991 to that in 1995?
Give a very brief answer. 1.05. What is the ratio of the Electricity production(% of total) in Lower middle income in 1991 to that in 1995?
Make the answer very short. 0.94. What is the ratio of the Electricity production(% of total) in Luxembourg in 1991 to that in 1995?
Ensure brevity in your answer.  1.93. What is the ratio of the Electricity production(% of total) in Moldova in 1991 to that in 1995?
Offer a very short reply. 1.22. What is the ratio of the Electricity production(% of total) in Europe(developing only) in 1991 to that in 1996?
Offer a terse response. 1.13. What is the ratio of the Electricity production(% of total) in Lower middle income in 1991 to that in 1996?
Give a very brief answer. 0.95. What is the ratio of the Electricity production(% of total) in Luxembourg in 1991 to that in 1996?
Give a very brief answer. 2.48. What is the ratio of the Electricity production(% of total) of Moldova in 1991 to that in 1996?
Offer a terse response. 1.65. What is the ratio of the Electricity production(% of total) in Europe(developing only) in 1991 to that in 1997?
Provide a short and direct response. 1.12. What is the ratio of the Electricity production(% of total) of Lower middle income in 1991 to that in 1997?
Ensure brevity in your answer.  0.95. What is the ratio of the Electricity production(% of total) of Luxembourg in 1991 to that in 1997?
Your answer should be compact. 3.62. What is the ratio of the Electricity production(% of total) of Moldova in 1991 to that in 1997?
Make the answer very short. 4.03. What is the ratio of the Electricity production(% of total) of Europe(developing only) in 1992 to that in 1993?
Give a very brief answer. 1.06. What is the ratio of the Electricity production(% of total) of Luxembourg in 1992 to that in 1993?
Offer a terse response. 0.95. What is the ratio of the Electricity production(% of total) in Moldova in 1992 to that in 1993?
Keep it short and to the point. 0.88. What is the ratio of the Electricity production(% of total) of Europe(developing only) in 1992 to that in 1994?
Make the answer very short. 1.06. What is the ratio of the Electricity production(% of total) in Lower middle income in 1992 to that in 1994?
Keep it short and to the point. 1. What is the ratio of the Electricity production(% of total) of Luxembourg in 1992 to that in 1994?
Your answer should be very brief. 1.07. What is the ratio of the Electricity production(% of total) in Moldova in 1992 to that in 1994?
Provide a short and direct response. 0.79. What is the ratio of the Electricity production(% of total) in Europe(developing only) in 1992 to that in 1995?
Keep it short and to the point. 1.09. What is the ratio of the Electricity production(% of total) in Lower middle income in 1992 to that in 1995?
Your answer should be compact. 0.98. What is the ratio of the Electricity production(% of total) in Luxembourg in 1992 to that in 1995?
Give a very brief answer. 1.84. What is the ratio of the Electricity production(% of total) in Moldova in 1992 to that in 1995?
Keep it short and to the point. 1.2. What is the ratio of the Electricity production(% of total) in Europe(developing only) in 1992 to that in 1996?
Give a very brief answer. 1.18. What is the ratio of the Electricity production(% of total) of Lower middle income in 1992 to that in 1996?
Your answer should be compact. 0.99. What is the ratio of the Electricity production(% of total) in Luxembourg in 1992 to that in 1996?
Offer a very short reply. 2.37. What is the ratio of the Electricity production(% of total) in Moldova in 1992 to that in 1996?
Your answer should be very brief. 1.62. What is the ratio of the Electricity production(% of total) of Europe(developing only) in 1992 to that in 1997?
Give a very brief answer. 1.17. What is the ratio of the Electricity production(% of total) of Lower middle income in 1992 to that in 1997?
Offer a very short reply. 0.98. What is the ratio of the Electricity production(% of total) in Luxembourg in 1992 to that in 1997?
Your answer should be very brief. 3.46. What is the ratio of the Electricity production(% of total) of Moldova in 1992 to that in 1997?
Make the answer very short. 3.96. What is the ratio of the Electricity production(% of total) in Europe(developing only) in 1993 to that in 1994?
Your answer should be compact. 1. What is the ratio of the Electricity production(% of total) of Lower middle income in 1993 to that in 1994?
Make the answer very short. 1.01. What is the ratio of the Electricity production(% of total) of Luxembourg in 1993 to that in 1994?
Offer a very short reply. 1.12. What is the ratio of the Electricity production(% of total) in Moldova in 1993 to that in 1994?
Provide a succinct answer. 0.9. What is the ratio of the Electricity production(% of total) in Europe(developing only) in 1993 to that in 1995?
Your response must be concise. 1.03. What is the ratio of the Electricity production(% of total) in Lower middle income in 1993 to that in 1995?
Give a very brief answer. 0.98. What is the ratio of the Electricity production(% of total) of Luxembourg in 1993 to that in 1995?
Ensure brevity in your answer.  1.93. What is the ratio of the Electricity production(% of total) of Moldova in 1993 to that in 1995?
Your response must be concise. 1.36. What is the ratio of the Electricity production(% of total) of Europe(developing only) in 1993 to that in 1996?
Keep it short and to the point. 1.11. What is the ratio of the Electricity production(% of total) of Luxembourg in 1993 to that in 1996?
Ensure brevity in your answer.  2.48. What is the ratio of the Electricity production(% of total) in Moldova in 1993 to that in 1996?
Your answer should be compact. 1.84. What is the ratio of the Electricity production(% of total) of Europe(developing only) in 1993 to that in 1997?
Offer a terse response. 1.1. What is the ratio of the Electricity production(% of total) in Lower middle income in 1993 to that in 1997?
Give a very brief answer. 0.99. What is the ratio of the Electricity production(% of total) of Luxembourg in 1993 to that in 1997?
Keep it short and to the point. 3.62. What is the ratio of the Electricity production(% of total) of Moldova in 1993 to that in 1997?
Provide a succinct answer. 4.51. What is the ratio of the Electricity production(% of total) in Europe(developing only) in 1994 to that in 1995?
Provide a short and direct response. 1.03. What is the ratio of the Electricity production(% of total) in Lower middle income in 1994 to that in 1995?
Give a very brief answer. 0.97. What is the ratio of the Electricity production(% of total) of Luxembourg in 1994 to that in 1995?
Give a very brief answer. 1.72. What is the ratio of the Electricity production(% of total) in Moldova in 1994 to that in 1995?
Give a very brief answer. 1.51. What is the ratio of the Electricity production(% of total) in Europe(developing only) in 1994 to that in 1996?
Offer a very short reply. 1.12. What is the ratio of the Electricity production(% of total) of Lower middle income in 1994 to that in 1996?
Keep it short and to the point. 0.98. What is the ratio of the Electricity production(% of total) of Luxembourg in 1994 to that in 1996?
Offer a terse response. 2.21. What is the ratio of the Electricity production(% of total) in Moldova in 1994 to that in 1996?
Provide a succinct answer. 2.05. What is the ratio of the Electricity production(% of total) in Europe(developing only) in 1994 to that in 1997?
Keep it short and to the point. 1.1. What is the ratio of the Electricity production(% of total) of Luxembourg in 1994 to that in 1997?
Offer a very short reply. 3.23. What is the ratio of the Electricity production(% of total) in Moldova in 1994 to that in 1997?
Provide a short and direct response. 5.02. What is the ratio of the Electricity production(% of total) in Europe(developing only) in 1995 to that in 1996?
Give a very brief answer. 1.08. What is the ratio of the Electricity production(% of total) of Lower middle income in 1995 to that in 1996?
Ensure brevity in your answer.  1.01. What is the ratio of the Electricity production(% of total) of Luxembourg in 1995 to that in 1996?
Provide a succinct answer. 1.28. What is the ratio of the Electricity production(% of total) of Moldova in 1995 to that in 1996?
Your answer should be compact. 1.36. What is the ratio of the Electricity production(% of total) in Europe(developing only) in 1995 to that in 1997?
Your answer should be very brief. 1.07. What is the ratio of the Electricity production(% of total) in Lower middle income in 1995 to that in 1997?
Give a very brief answer. 1.01. What is the ratio of the Electricity production(% of total) of Luxembourg in 1995 to that in 1997?
Make the answer very short. 1.88. What is the ratio of the Electricity production(% of total) of Moldova in 1995 to that in 1997?
Keep it short and to the point. 3.32. What is the ratio of the Electricity production(% of total) in Europe(developing only) in 1996 to that in 1997?
Ensure brevity in your answer.  0.99. What is the ratio of the Electricity production(% of total) of Lower middle income in 1996 to that in 1997?
Your answer should be compact. 1. What is the ratio of the Electricity production(% of total) of Luxembourg in 1996 to that in 1997?
Your answer should be compact. 1.46. What is the ratio of the Electricity production(% of total) in Moldova in 1996 to that in 1997?
Offer a very short reply. 2.45. What is the difference between the highest and the second highest Electricity production(% of total) of Europe(developing only)?
Provide a short and direct response. 1.09. What is the difference between the highest and the second highest Electricity production(% of total) of Lower middle income?
Provide a short and direct response. 0.25. What is the difference between the highest and the second highest Electricity production(% of total) in Luxembourg?
Keep it short and to the point. 1.48. What is the difference between the highest and the second highest Electricity production(% of total) in Moldova?
Offer a terse response. 3.85. What is the difference between the highest and the lowest Electricity production(% of total) of Europe(developing only)?
Provide a succinct answer. 5.49. What is the difference between the highest and the lowest Electricity production(% of total) in Lower middle income?
Your answer should be very brief. 3.11. What is the difference between the highest and the lowest Electricity production(% of total) of Luxembourg?
Offer a terse response. 55.75. What is the difference between the highest and the lowest Electricity production(% of total) of Moldova?
Your answer should be compact. 30.4. 